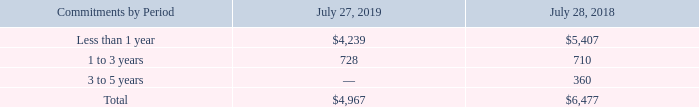The following table summarizes our purchase commitments with contract manufacturers and suppliers as of the respective period ends (in millions):
Purchase commitments with contract manufacturers and suppliers decreased by approximately 23% compared to the end of fiscal 2018. On a combined basis, inventories and purchase commitments with contract manufacturers and suppliers decreased by 24% compared with the end of fiscal 2018.
Inventory and supply chain management remain areas of focus as we balance the need to maintain supply chain flexibility to help ensure competitive lead times with the risk of inventory obsolescence because of rapidly changing technology and customer requirements. We believe the amount of our inventory and purchase commitments is appropriate for our revenue levels.
Why is inventory and supply chain management an area of focus for the company? We balance the need to maintain supply chain flexibility to help ensure competitive lead times with the risk of inventory obsolescence because of rapidly changing technology and customer requirements. What were the purchase commitments that were less than 1 year in 2019?
Answer scale should be: million. 4,239. What were the total purchase commitments in 2018?
Answer scale should be: million. 6,477. What was the change in purchase commitments that were less than 1 year between 2018 and 2019?
Answer scale should be: million. 4,239-5,407
Answer: -1168. How many years did commitments that were 1 to 3 years exceed $700 million? 2019##2018
Answer: 2. What were the commitments that were less than 1 year as a percentage of total purchase commitments in 2019?
Answer scale should be: percent. 4,239/4,967
Answer: 85.34. 